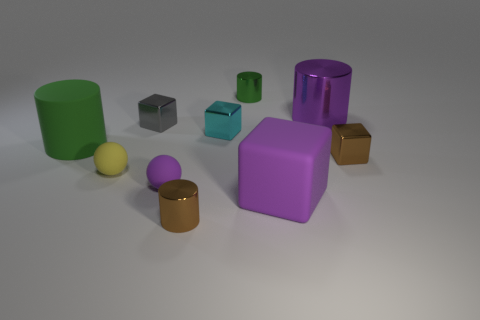The cylinder that is the same color as the big cube is what size?
Give a very brief answer. Large. Are the large purple object in front of the tiny gray shiny object and the large green thing made of the same material?
Offer a very short reply. Yes. Are there any metal cylinders that have the same color as the large metal object?
Ensure brevity in your answer.  No. Is the shape of the small brown metallic object that is on the left side of the big rubber cube the same as the object on the right side of the purple cylinder?
Keep it short and to the point. No. Is there a cylinder made of the same material as the large green object?
Your answer should be very brief. No. What number of green objects are either tiny metallic cubes or big objects?
Provide a succinct answer. 1. There is a object that is behind the brown metallic cylinder and in front of the purple matte ball; what is its size?
Ensure brevity in your answer.  Large. Is the number of green rubber cylinders that are behind the purple cylinder greater than the number of large things?
Your answer should be very brief. No. What number of cylinders are either green things or large purple rubber things?
Your response must be concise. 2. There is a shiny thing that is left of the large metallic cylinder and in front of the big matte cylinder; what shape is it?
Offer a very short reply. Cylinder. 